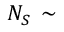Convert formula to latex. <formula><loc_0><loc_0><loc_500><loc_500>N _ { S } \, \sim</formula> 